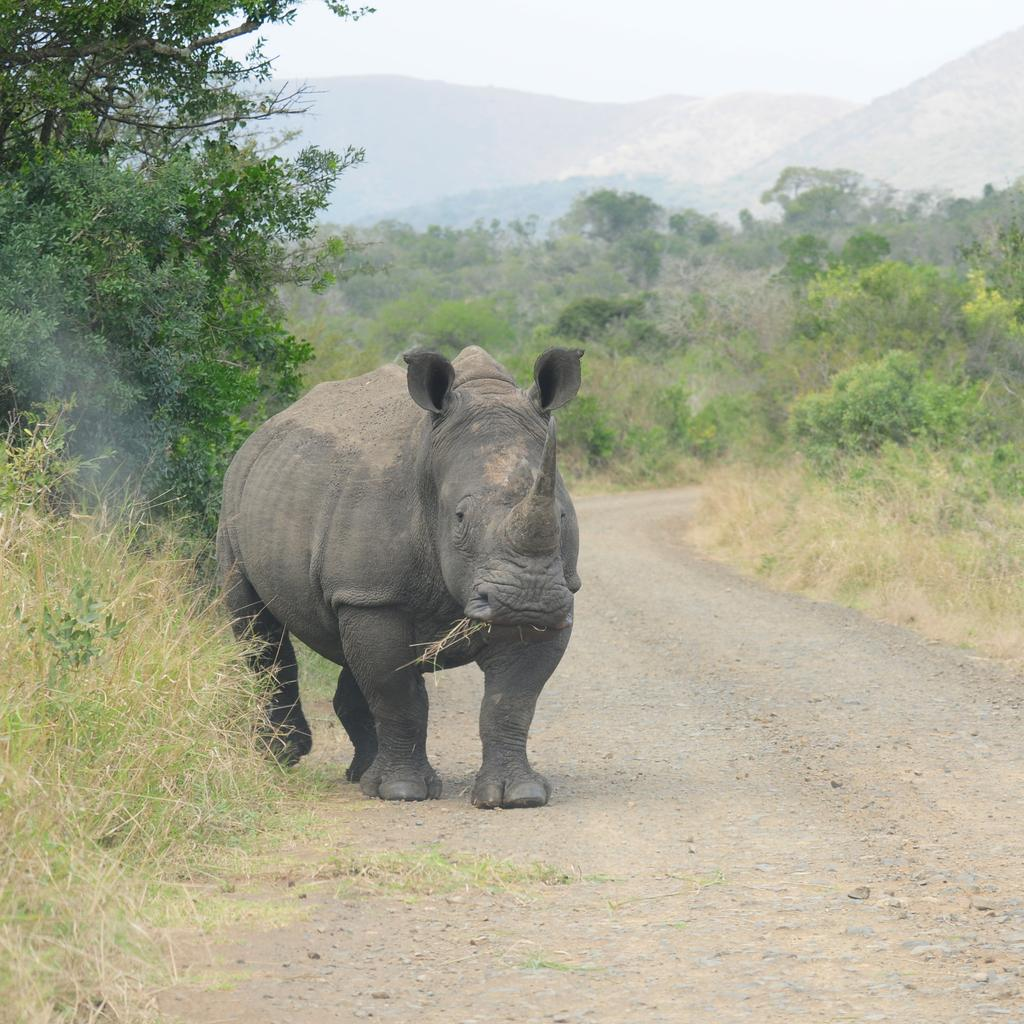What animal is on the road in the image? There is a rhinoceros on the road in the image. What can be seen in the background of the image? There are trees, hills, and the sky visible in the background of the image. What type of letters does the rhinoceros write in the image? There are no letters or writing activity present in the image, as it features a rhinoceros on the road with a background of trees, hills, and the sky. 